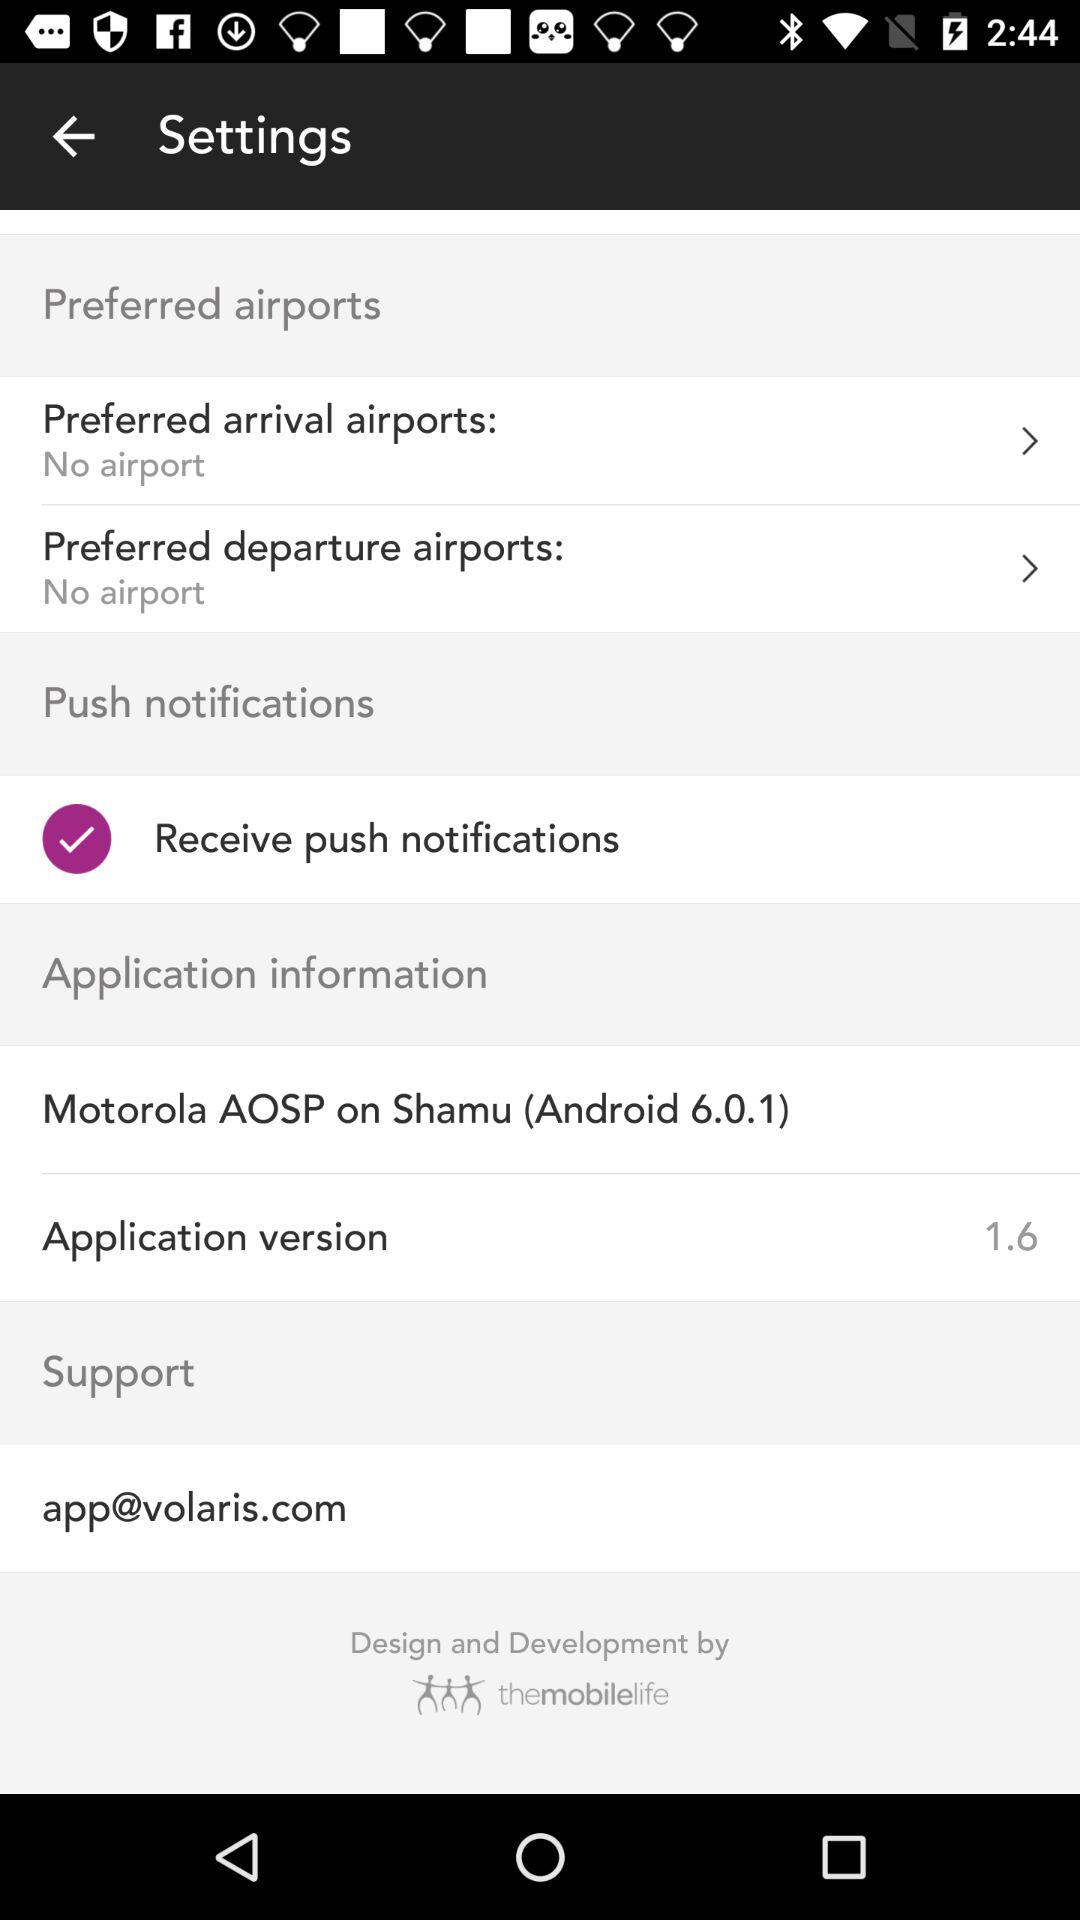What is the status of the "Receive push notifications"? The status is "on". 